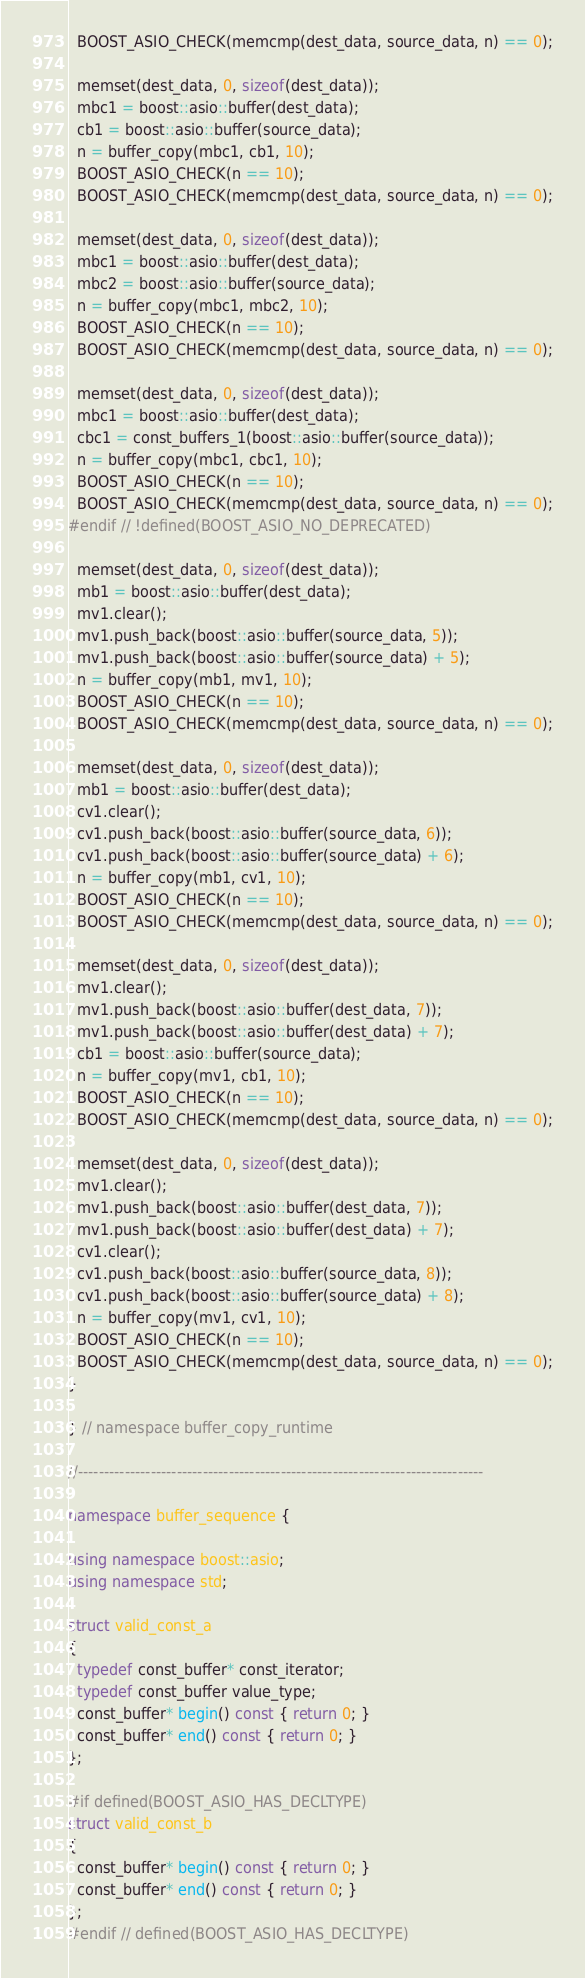<code> <loc_0><loc_0><loc_500><loc_500><_C++_>  BOOST_ASIO_CHECK(memcmp(dest_data, source_data, n) == 0);

  memset(dest_data, 0, sizeof(dest_data));
  mbc1 = boost::asio::buffer(dest_data);
  cb1 = boost::asio::buffer(source_data);
  n = buffer_copy(mbc1, cb1, 10);
  BOOST_ASIO_CHECK(n == 10);
  BOOST_ASIO_CHECK(memcmp(dest_data, source_data, n) == 0);

  memset(dest_data, 0, sizeof(dest_data));
  mbc1 = boost::asio::buffer(dest_data);
  mbc2 = boost::asio::buffer(source_data);
  n = buffer_copy(mbc1, mbc2, 10);
  BOOST_ASIO_CHECK(n == 10);
  BOOST_ASIO_CHECK(memcmp(dest_data, source_data, n) == 0);

  memset(dest_data, 0, sizeof(dest_data));
  mbc1 = boost::asio::buffer(dest_data);
  cbc1 = const_buffers_1(boost::asio::buffer(source_data));
  n = buffer_copy(mbc1, cbc1, 10);
  BOOST_ASIO_CHECK(n == 10);
  BOOST_ASIO_CHECK(memcmp(dest_data, source_data, n) == 0);
#endif // !defined(BOOST_ASIO_NO_DEPRECATED)

  memset(dest_data, 0, sizeof(dest_data));
  mb1 = boost::asio::buffer(dest_data);
  mv1.clear();
  mv1.push_back(boost::asio::buffer(source_data, 5));
  mv1.push_back(boost::asio::buffer(source_data) + 5);
  n = buffer_copy(mb1, mv1, 10);
  BOOST_ASIO_CHECK(n == 10);
  BOOST_ASIO_CHECK(memcmp(dest_data, source_data, n) == 0);

  memset(dest_data, 0, sizeof(dest_data));
  mb1 = boost::asio::buffer(dest_data);
  cv1.clear();
  cv1.push_back(boost::asio::buffer(source_data, 6));
  cv1.push_back(boost::asio::buffer(source_data) + 6);
  n = buffer_copy(mb1, cv1, 10);
  BOOST_ASIO_CHECK(n == 10);
  BOOST_ASIO_CHECK(memcmp(dest_data, source_data, n) == 0);

  memset(dest_data, 0, sizeof(dest_data));
  mv1.clear();
  mv1.push_back(boost::asio::buffer(dest_data, 7));
  mv1.push_back(boost::asio::buffer(dest_data) + 7);
  cb1 = boost::asio::buffer(source_data);
  n = buffer_copy(mv1, cb1, 10);
  BOOST_ASIO_CHECK(n == 10);
  BOOST_ASIO_CHECK(memcmp(dest_data, source_data, n) == 0);

  memset(dest_data, 0, sizeof(dest_data));
  mv1.clear();
  mv1.push_back(boost::asio::buffer(dest_data, 7));
  mv1.push_back(boost::asio::buffer(dest_data) + 7);
  cv1.clear();
  cv1.push_back(boost::asio::buffer(source_data, 8));
  cv1.push_back(boost::asio::buffer(source_data) + 8);
  n = buffer_copy(mv1, cv1, 10);
  BOOST_ASIO_CHECK(n == 10);
  BOOST_ASIO_CHECK(memcmp(dest_data, source_data, n) == 0);
}

} // namespace buffer_copy_runtime

//------------------------------------------------------------------------------

namespace buffer_sequence {

using namespace boost::asio;
using namespace std;

struct valid_const_a
{
  typedef const_buffer* const_iterator;
  typedef const_buffer value_type;
  const_buffer* begin() const { return 0; }
  const_buffer* end() const { return 0; }
};

#if defined(BOOST_ASIO_HAS_DECLTYPE)
struct valid_const_b
{
  const_buffer* begin() const { return 0; }
  const_buffer* end() const { return 0; }
};
#endif // defined(BOOST_ASIO_HAS_DECLTYPE)
</code> 